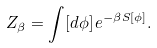Convert formula to latex. <formula><loc_0><loc_0><loc_500><loc_500>Z _ { \beta } = \int [ d \phi ] \, e ^ { - \beta S [ \phi ] } .</formula> 